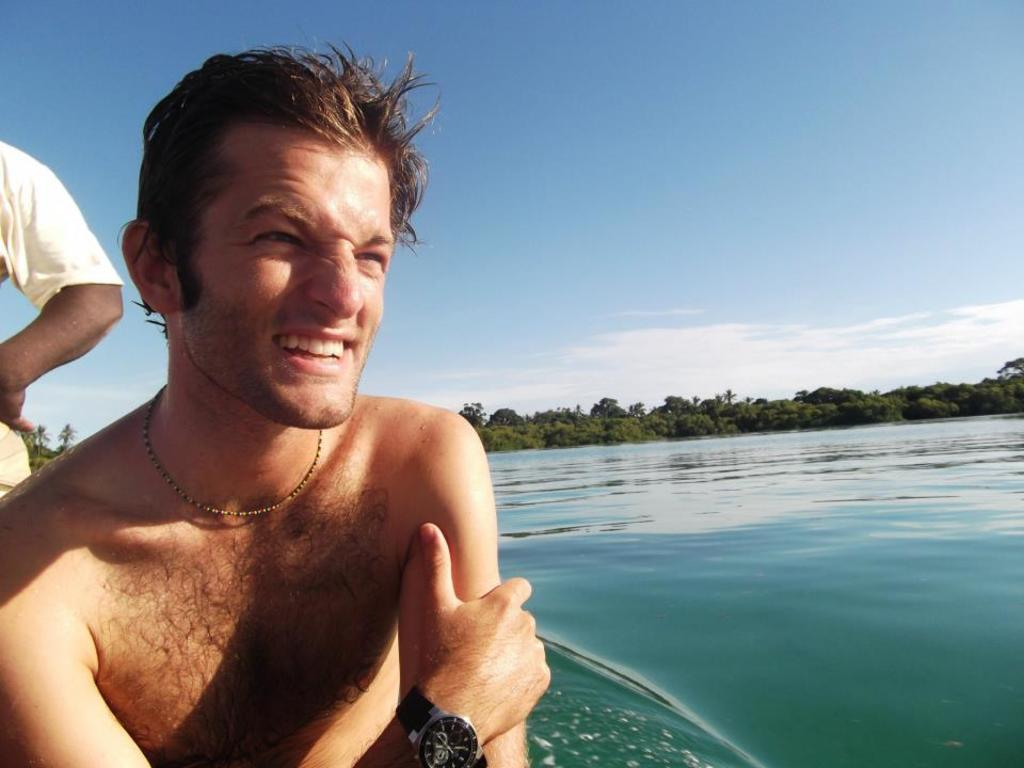What is the man in the image doing? The man is sitting in the image. What is the man's facial expression? The man is smiling. Who else is present in the image besides the man? There is a person standing in the image. What can be seen in the background of the image? There is water, trees, and the sky visible in the image. What type of underwear is the man wearing in the image? There is no information about the man's underwear in the image, so it cannot be determined. What is the man using his tongue for in the image? There is no indication that the man is using his tongue for any specific purpose in the image. 